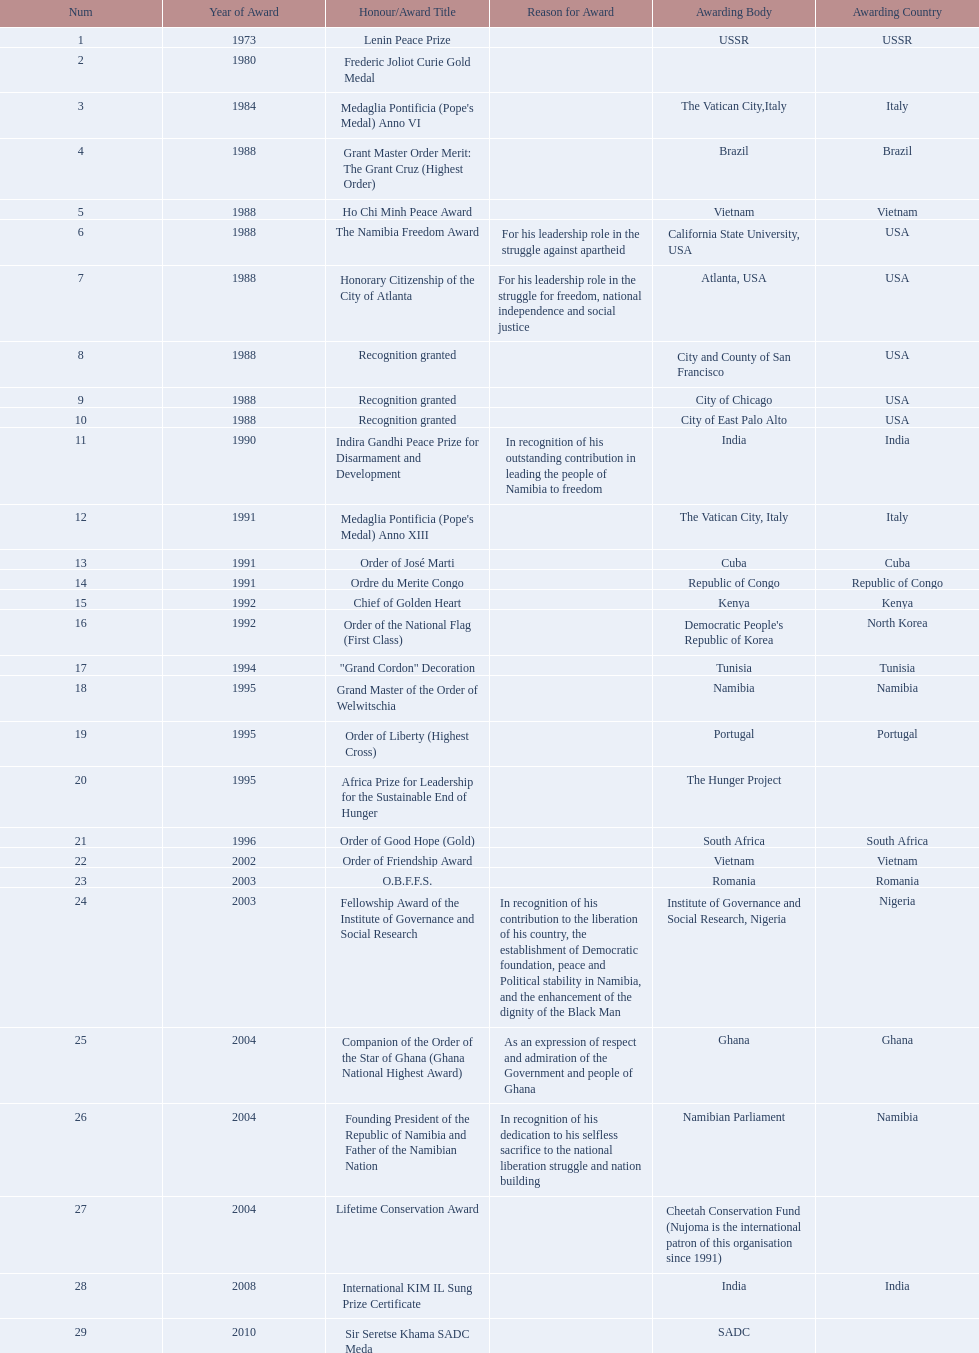What awards has sam nujoma been awarded? Lenin Peace Prize, Frederic Joliot Curie Gold Medal, Medaglia Pontificia (Pope's Medal) Anno VI, Grant Master Order Merit: The Grant Cruz (Highest Order), Ho Chi Minh Peace Award, The Namibia Freedom Award, Honorary Citizenship of the City of Atlanta, Recognition granted, Recognition granted, Recognition granted, Indira Gandhi Peace Prize for Disarmament and Development, Medaglia Pontificia (Pope's Medal) Anno XIII, Order of José Marti, Ordre du Merite Congo, Chief of Golden Heart, Order of the National Flag (First Class), "Grand Cordon" Decoration, Grand Master of the Order of Welwitschia, Order of Liberty (Highest Cross), Africa Prize for Leadership for the Sustainable End of Hunger, Order of Good Hope (Gold), Order of Friendship Award, O.B.F.F.S., Fellowship Award of the Institute of Governance and Social Research, Companion of the Order of the Star of Ghana (Ghana National Highest Award), Founding President of the Republic of Namibia and Father of the Namibian Nation, Lifetime Conservation Award, International KIM IL Sung Prize Certificate, Sir Seretse Khama SADC Meda. By which awarding body did sam nujoma receive the o.b.f.f.s award? Romania. 